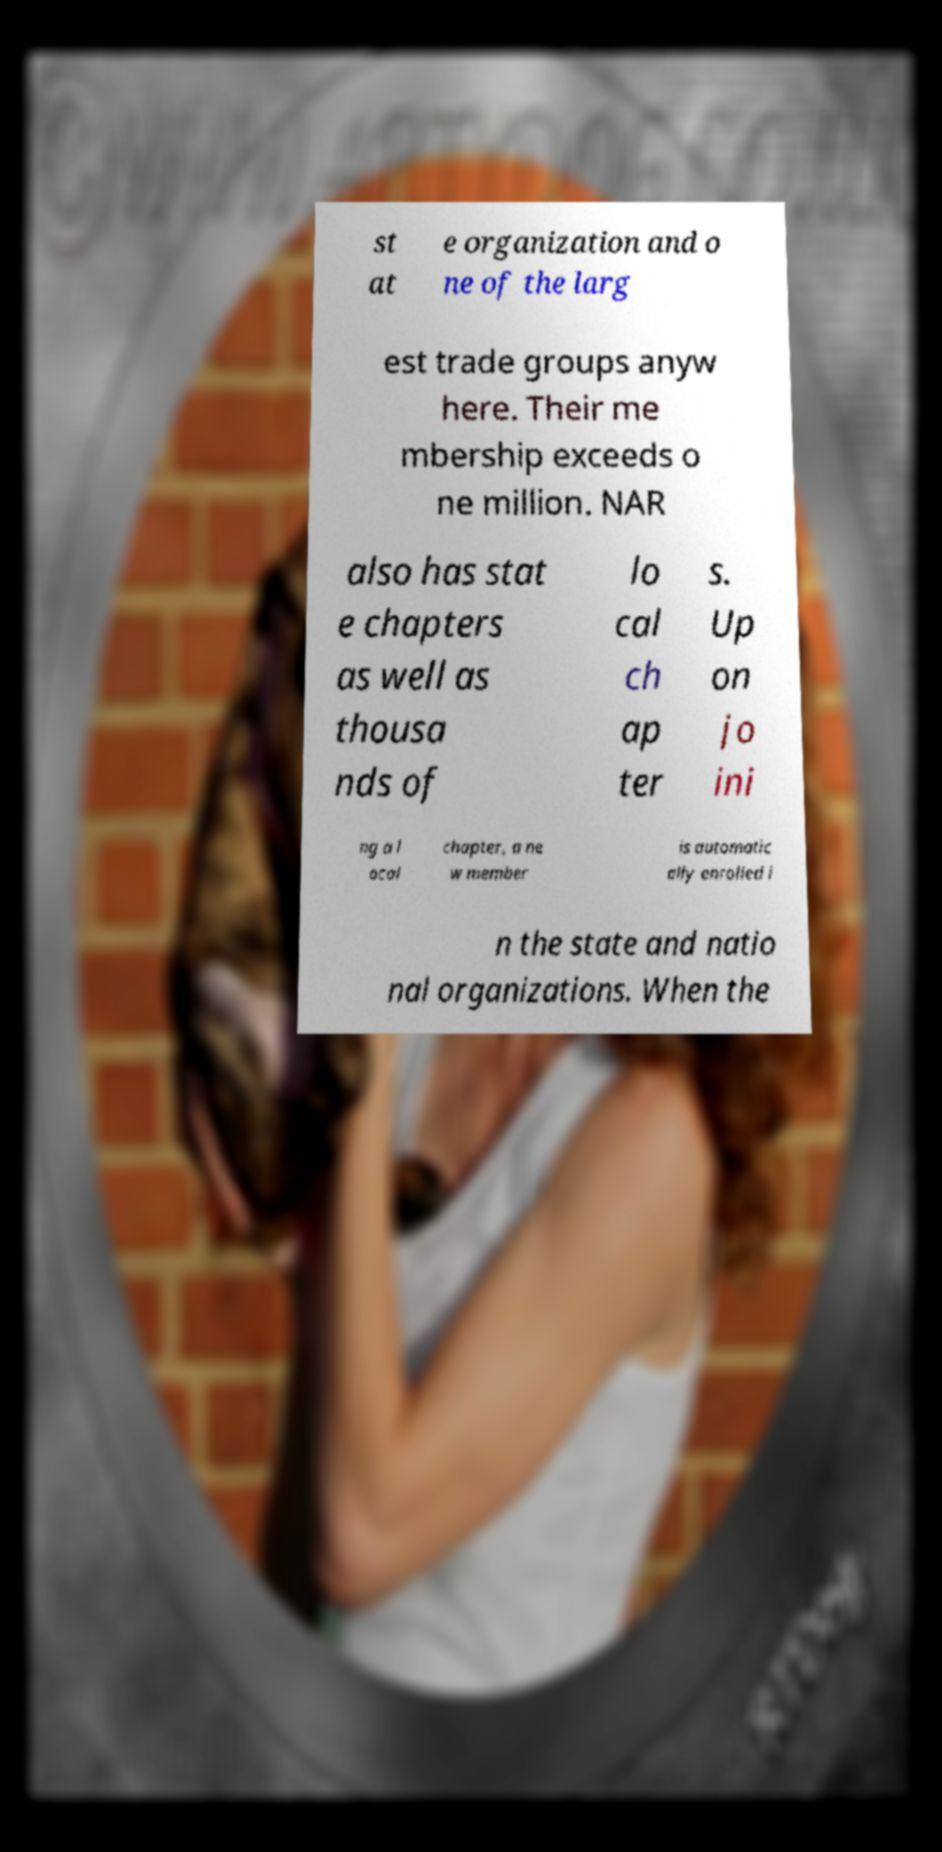Please read and relay the text visible in this image. What does it say? st at e organization and o ne of the larg est trade groups anyw here. Their me mbership exceeds o ne million. NAR also has stat e chapters as well as thousa nds of lo cal ch ap ter s. Up on jo ini ng a l ocal chapter, a ne w member is automatic ally enrolled i n the state and natio nal organizations. When the 